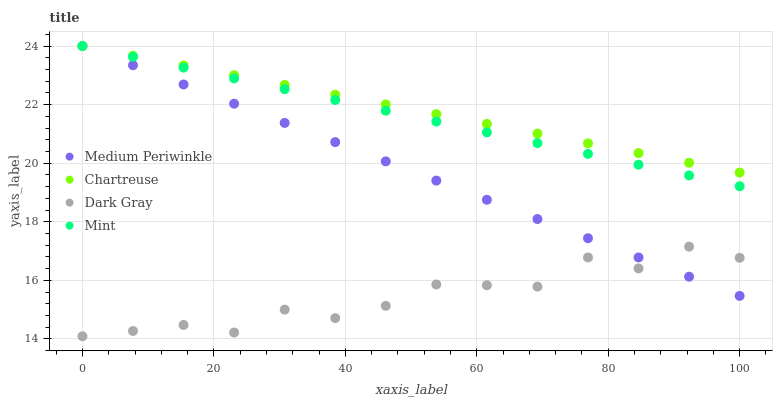Does Dark Gray have the minimum area under the curve?
Answer yes or no. Yes. Does Chartreuse have the maximum area under the curve?
Answer yes or no. Yes. Does Mint have the minimum area under the curve?
Answer yes or no. No. Does Mint have the maximum area under the curve?
Answer yes or no. No. Is Medium Periwinkle the smoothest?
Answer yes or no. Yes. Is Dark Gray the roughest?
Answer yes or no. Yes. Is Mint the smoothest?
Answer yes or no. No. Is Mint the roughest?
Answer yes or no. No. Does Dark Gray have the lowest value?
Answer yes or no. Yes. Does Mint have the lowest value?
Answer yes or no. No. Does Medium Periwinkle have the highest value?
Answer yes or no. Yes. Is Dark Gray less than Chartreuse?
Answer yes or no. Yes. Is Mint greater than Dark Gray?
Answer yes or no. Yes. Does Mint intersect Medium Periwinkle?
Answer yes or no. Yes. Is Mint less than Medium Periwinkle?
Answer yes or no. No. Is Mint greater than Medium Periwinkle?
Answer yes or no. No. Does Dark Gray intersect Chartreuse?
Answer yes or no. No. 